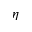Convert formula to latex. <formula><loc_0><loc_0><loc_500><loc_500>\eta</formula> 